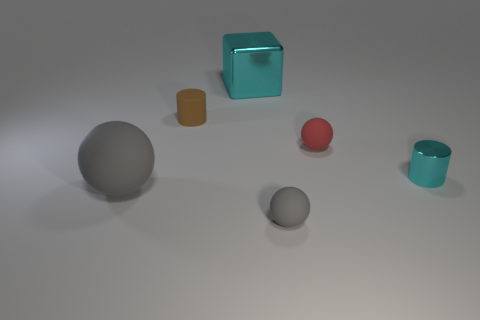Add 2 small gray rubber spheres. How many objects exist? 8 Subtract all big gray balls. How many balls are left? 2 Subtract all red spheres. How many spheres are left? 2 Subtract all cylinders. How many objects are left? 4 Subtract 1 blocks. How many blocks are left? 0 Subtract all blue blocks. How many gray spheres are left? 2 Subtract all cyan objects. Subtract all balls. How many objects are left? 1 Add 1 gray rubber spheres. How many gray rubber spheres are left? 3 Add 1 brown matte spheres. How many brown matte spheres exist? 1 Subtract 0 blue cylinders. How many objects are left? 6 